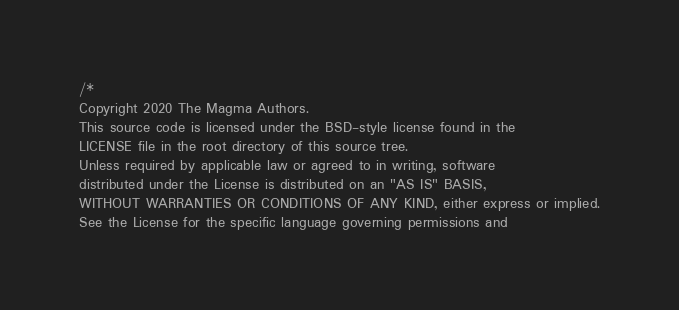Convert code to text. <code><loc_0><loc_0><loc_500><loc_500><_C_>/*
Copyright 2020 The Magma Authors.
This source code is licensed under the BSD-style license found in the
LICENSE file in the root directory of this source tree.
Unless required by applicable law or agreed to in writing, software
distributed under the License is distributed on an "AS IS" BASIS,
WITHOUT WARRANTIES OR CONDITIONS OF ANY KIND, either express or implied.
See the License for the specific language governing permissions and</code> 